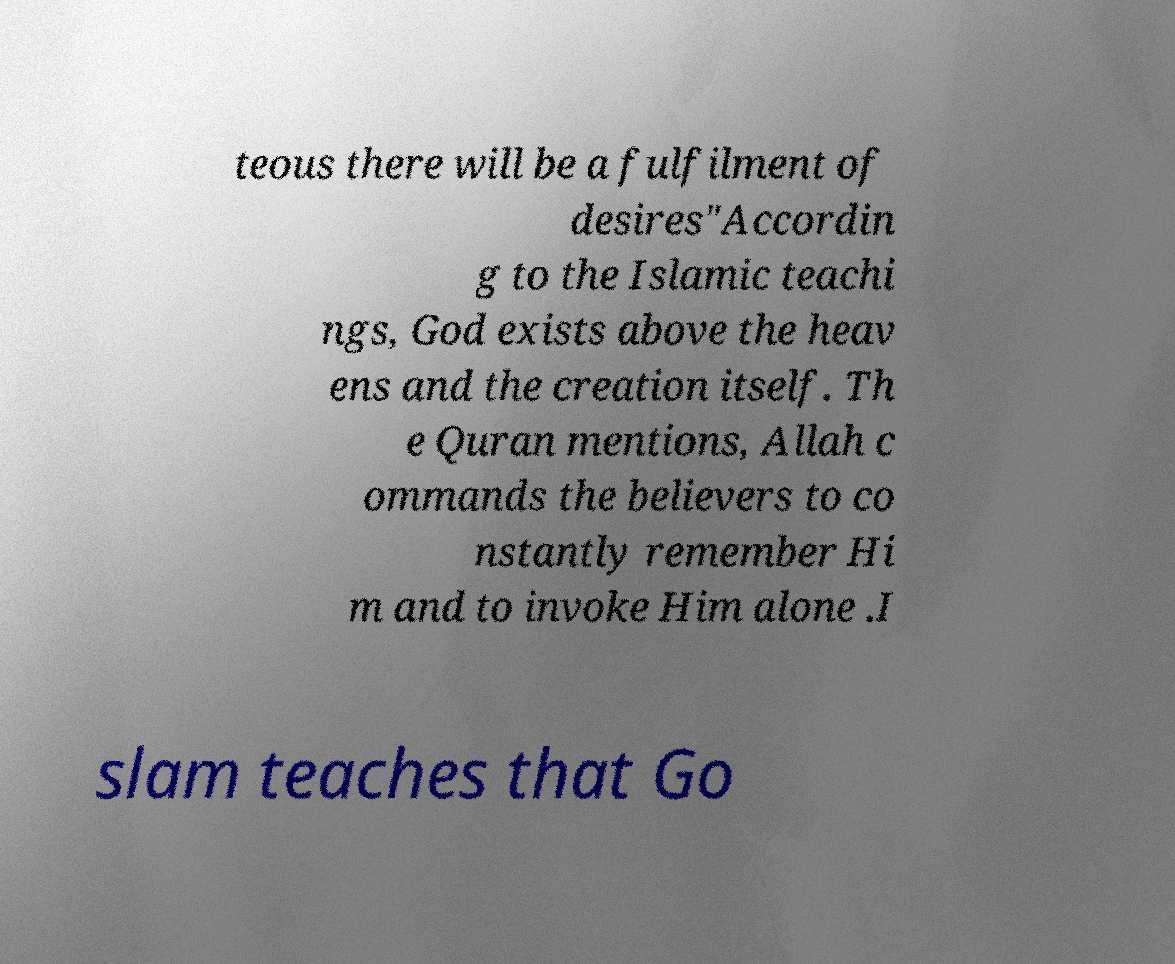Could you extract and type out the text from this image? teous there will be a fulfilment of desires"Accordin g to the Islamic teachi ngs, God exists above the heav ens and the creation itself. Th e Quran mentions, Allah c ommands the believers to co nstantly remember Hi m and to invoke Him alone .I slam teaches that Go 